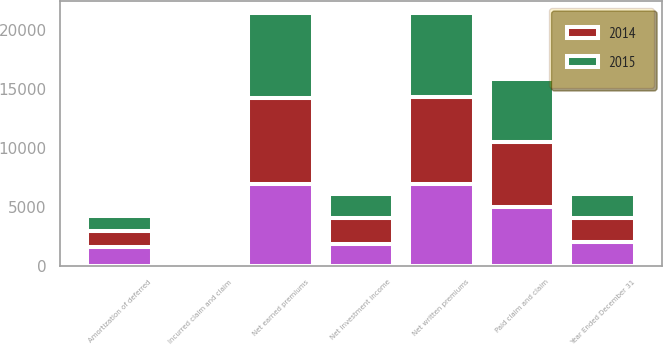Convert chart to OTSL. <chart><loc_0><loc_0><loc_500><loc_500><stacked_bar_chart><ecel><fcel>Year Ended December 31<fcel>Net written premiums<fcel>Net earned premiums<fcel>Net investment income<fcel>Incurred claim and claim<fcel>Amortization of deferred<fcel>Paid claim and claim<nl><fcel>nan<fcel>2015<fcel>6962<fcel>6921<fcel>1807<fcel>255<fcel>1540<fcel>4945<nl><fcel>2015<fcel>2014<fcel>7088<fcel>7212<fcel>2031<fcel>39<fcel>1317<fcel>5297<nl><fcel>2014<fcel>2013<fcel>7348<fcel>7271<fcel>2240<fcel>115<fcel>1362<fcel>5566<nl></chart> 